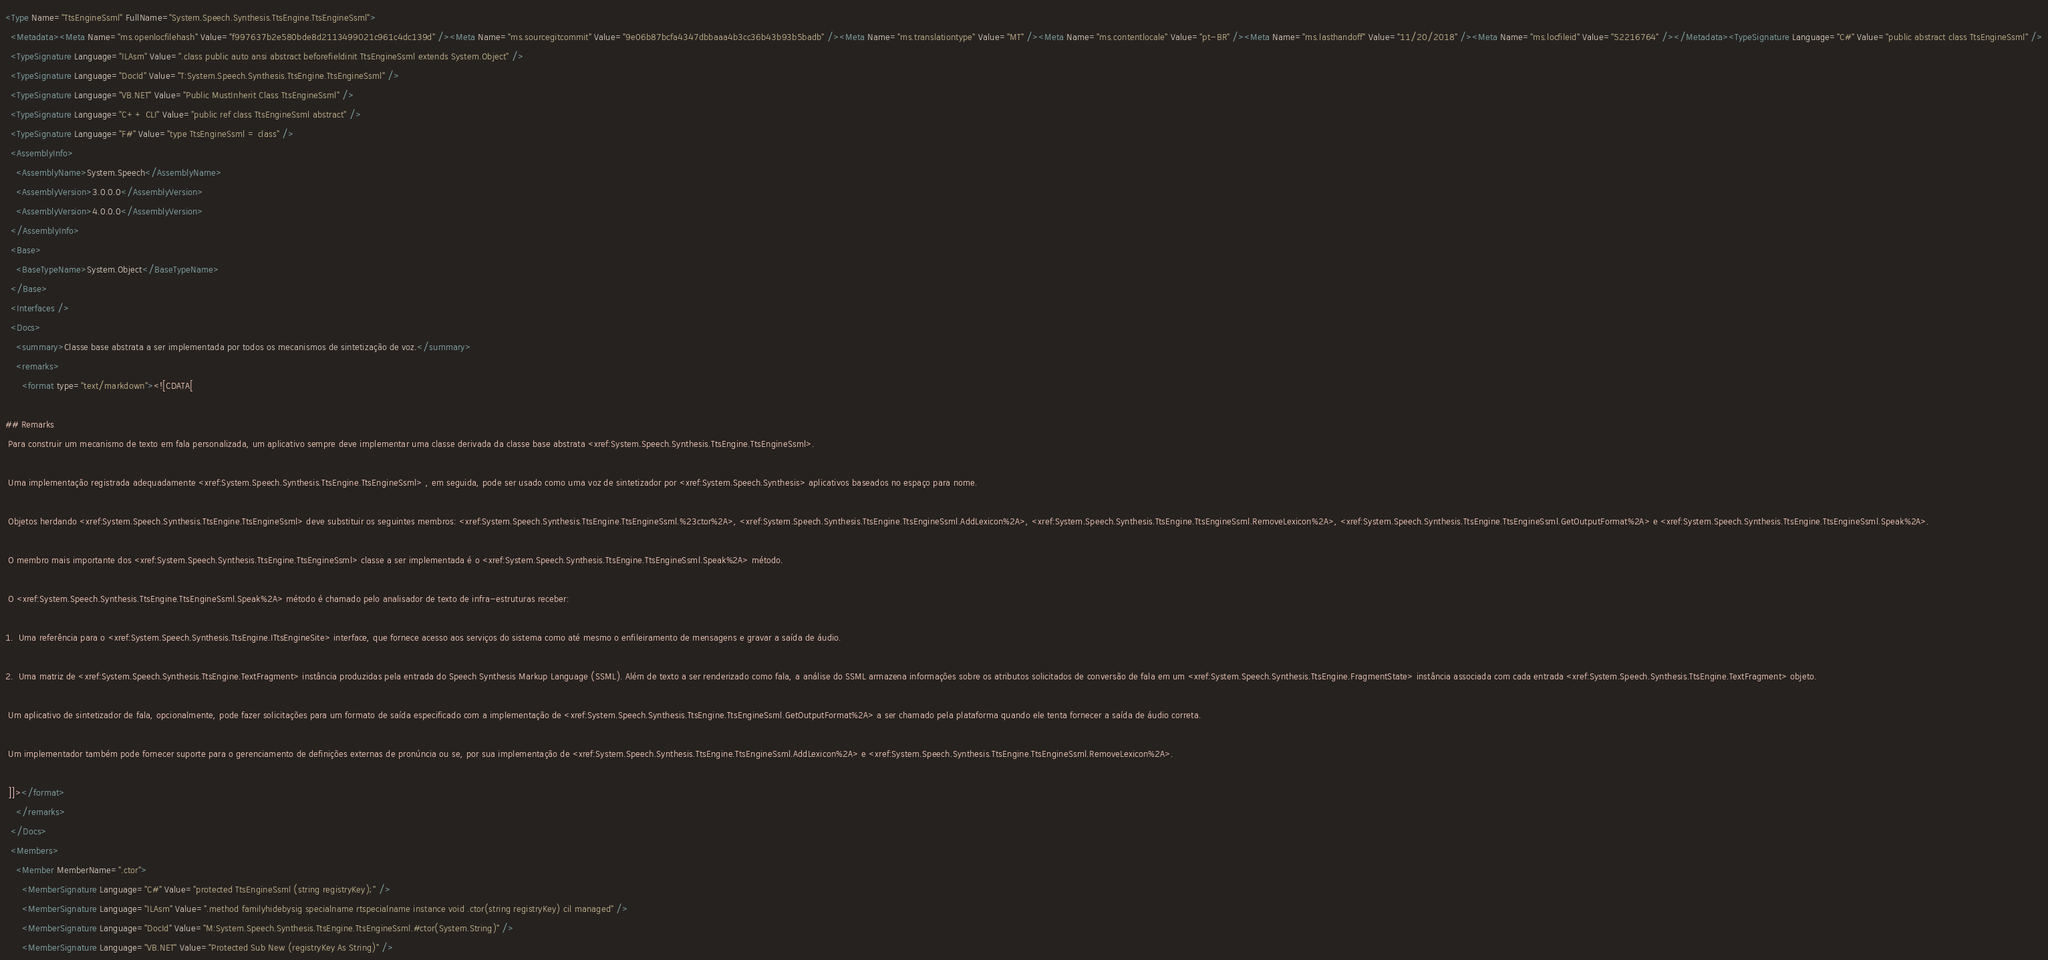Convert code to text. <code><loc_0><loc_0><loc_500><loc_500><_XML_><Type Name="TtsEngineSsml" FullName="System.Speech.Synthesis.TtsEngine.TtsEngineSsml">
  <Metadata><Meta Name="ms.openlocfilehash" Value="f997637b2e580bde8d2113499021c961c4dc139d" /><Meta Name="ms.sourcegitcommit" Value="9e06b87bcfa4347dbbaaa4b3cc36b43b93b5badb" /><Meta Name="ms.translationtype" Value="MT" /><Meta Name="ms.contentlocale" Value="pt-BR" /><Meta Name="ms.lasthandoff" Value="11/20/2018" /><Meta Name="ms.locfileid" Value="52216764" /></Metadata><TypeSignature Language="C#" Value="public abstract class TtsEngineSsml" />
  <TypeSignature Language="ILAsm" Value=".class public auto ansi abstract beforefieldinit TtsEngineSsml extends System.Object" />
  <TypeSignature Language="DocId" Value="T:System.Speech.Synthesis.TtsEngine.TtsEngineSsml" />
  <TypeSignature Language="VB.NET" Value="Public MustInherit Class TtsEngineSsml" />
  <TypeSignature Language="C++ CLI" Value="public ref class TtsEngineSsml abstract" />
  <TypeSignature Language="F#" Value="type TtsEngineSsml = class" />
  <AssemblyInfo>
    <AssemblyName>System.Speech</AssemblyName>
    <AssemblyVersion>3.0.0.0</AssemblyVersion>
    <AssemblyVersion>4.0.0.0</AssemblyVersion>
  </AssemblyInfo>
  <Base>
    <BaseTypeName>System.Object</BaseTypeName>
  </Base>
  <Interfaces />
  <Docs>
    <summary>Classe base abstrata a ser implementada por todos os mecanismos de sintetização de voz.</summary>
    <remarks>
      <format type="text/markdown"><![CDATA[  
  
## Remarks  
 Para construir um mecanismo de texto em fala personalizada, um aplicativo sempre deve implementar uma classe derivada da classe base abstrata <xref:System.Speech.Synthesis.TtsEngine.TtsEngineSsml>.  
  
 Uma implementação registrada adequadamente <xref:System.Speech.Synthesis.TtsEngine.TtsEngineSsml> , em seguida, pode ser usado como uma voz de sintetizador por <xref:System.Speech.Synthesis> aplicativos baseados no espaço para nome.  
  
 Objetos herdando <xref:System.Speech.Synthesis.TtsEngine.TtsEngineSsml> deve substituir os seguintes membros: <xref:System.Speech.Synthesis.TtsEngine.TtsEngineSsml.%23ctor%2A>, <xref:System.Speech.Synthesis.TtsEngine.TtsEngineSsml.AddLexicon%2A>, <xref:System.Speech.Synthesis.TtsEngine.TtsEngineSsml.RemoveLexicon%2A>, <xref:System.Speech.Synthesis.TtsEngine.TtsEngineSsml.GetOutputFormat%2A> e <xref:System.Speech.Synthesis.TtsEngine.TtsEngineSsml.Speak%2A>.  
  
 O membro mais importante dos <xref:System.Speech.Synthesis.TtsEngine.TtsEngineSsml> classe a ser implementada é o <xref:System.Speech.Synthesis.TtsEngine.TtsEngineSsml.Speak%2A> método.  
  
 O <xref:System.Speech.Synthesis.TtsEngine.TtsEngineSsml.Speak%2A> método é chamado pelo analisador de texto de infra-estruturas receber:  
  
1.  Uma referência para o <xref:System.Speech.Synthesis.TtsEngine.ITtsEngineSite> interface, que fornece acesso aos serviços do sistema como até mesmo o enfileiramento de mensagens e gravar a saída de áudio.  
  
2.  Uma matriz de <xref:System.Speech.Synthesis.TtsEngine.TextFragment> instância produzidas pela entrada do Speech Synthesis Markup Language (SSML). Além de texto a ser renderizado como fala, a análise do SSML armazena informações sobre os atributos solicitados de conversão de fala em um <xref:System.Speech.Synthesis.TtsEngine.FragmentState> instância associada com cada entrada <xref:System.Speech.Synthesis.TtsEngine.TextFragment> objeto.  
  
 Um aplicativo de sintetizador de fala, opcionalmente, pode fazer solicitações para um formato de saída especificado com a implementação de <xref:System.Speech.Synthesis.TtsEngine.TtsEngineSsml.GetOutputFormat%2A> a ser chamado pela plataforma quando ele tenta fornecer a saída de áudio correta.  
  
 Um implementador também pode fornecer suporte para o gerenciamento de definições externas de pronúncia ou se, por sua implementação de <xref:System.Speech.Synthesis.TtsEngine.TtsEngineSsml.AddLexicon%2A> e <xref:System.Speech.Synthesis.TtsEngine.TtsEngineSsml.RemoveLexicon%2A>.  
  
 ]]></format>
    </remarks>
  </Docs>
  <Members>
    <Member MemberName=".ctor">
      <MemberSignature Language="C#" Value="protected TtsEngineSsml (string registryKey);" />
      <MemberSignature Language="ILAsm" Value=".method familyhidebysig specialname rtspecialname instance void .ctor(string registryKey) cil managed" />
      <MemberSignature Language="DocId" Value="M:System.Speech.Synthesis.TtsEngine.TtsEngineSsml.#ctor(System.String)" />
      <MemberSignature Language="VB.NET" Value="Protected Sub New (registryKey As String)" /></code> 